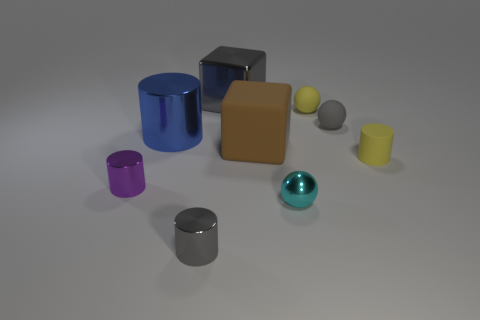What time of day does the lighting in this scene suggest? The lighting in the scene doesn't necessarily suggest a particular time of day, as it is a controlled environment with even, diffuse lighting, which is commonly used in studio settings. 